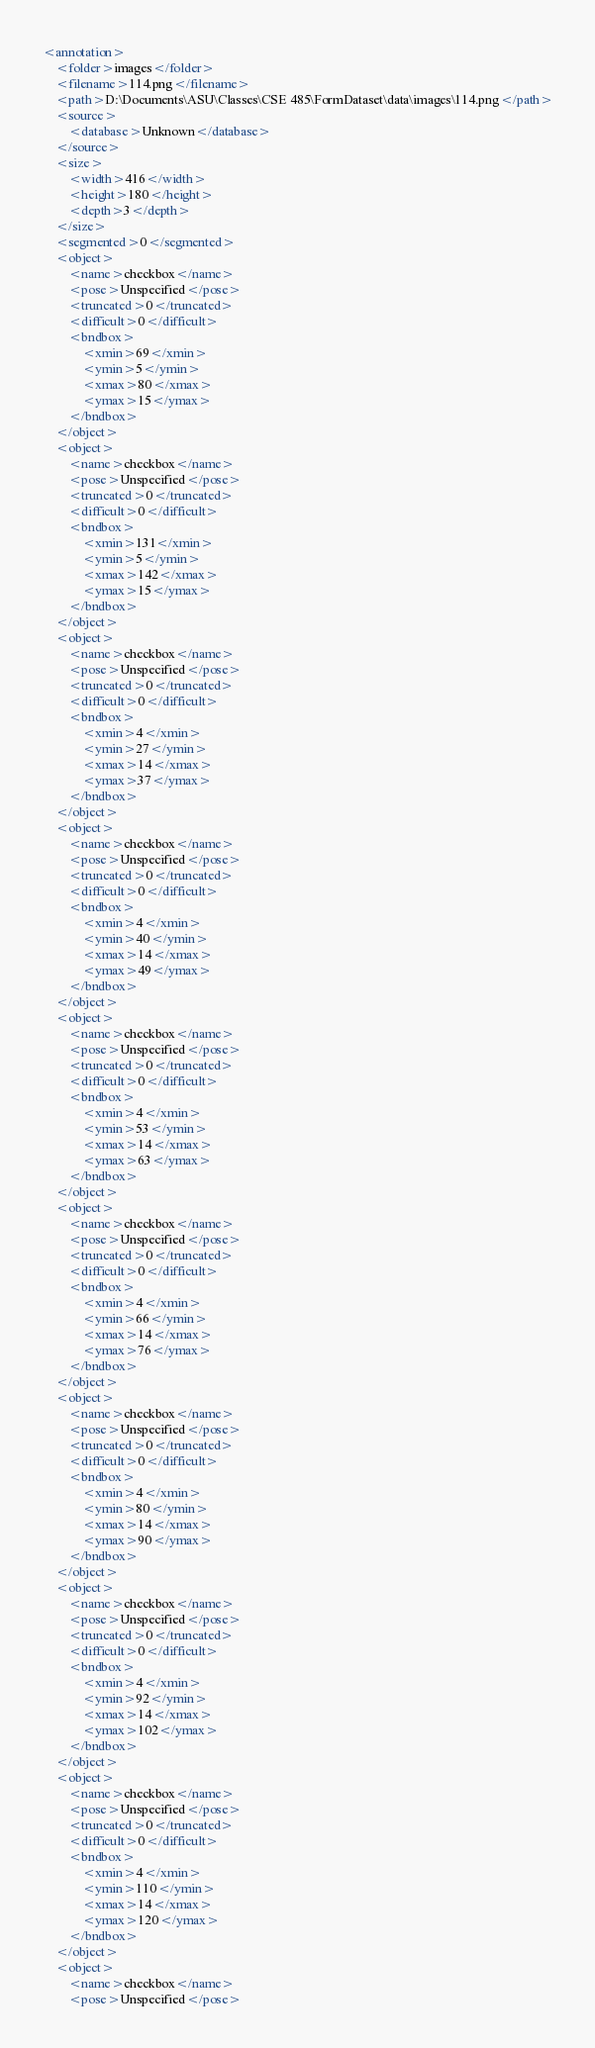Convert code to text. <code><loc_0><loc_0><loc_500><loc_500><_XML_><annotation>
	<folder>images</folder>
	<filename>114.png</filename>
	<path>D:\Documents\ASU\Classes\CSE 485\FormDataset\data\images\114.png</path>
	<source>
		<database>Unknown</database>
	</source>
	<size>
		<width>416</width>
		<height>180</height>
		<depth>3</depth>
	</size>
	<segmented>0</segmented>
	<object>
		<name>checkbox</name>
		<pose>Unspecified</pose>
		<truncated>0</truncated>
		<difficult>0</difficult>
		<bndbox>
			<xmin>69</xmin>
			<ymin>5</ymin>
			<xmax>80</xmax>
			<ymax>15</ymax>
		</bndbox>
	</object>
	<object>
		<name>checkbox</name>
		<pose>Unspecified</pose>
		<truncated>0</truncated>
		<difficult>0</difficult>
		<bndbox>
			<xmin>131</xmin>
			<ymin>5</ymin>
			<xmax>142</xmax>
			<ymax>15</ymax>
		</bndbox>
	</object>
	<object>
		<name>checkbox</name>
		<pose>Unspecified</pose>
		<truncated>0</truncated>
		<difficult>0</difficult>
		<bndbox>
			<xmin>4</xmin>
			<ymin>27</ymin>
			<xmax>14</xmax>
			<ymax>37</ymax>
		</bndbox>
	</object>
	<object>
		<name>checkbox</name>
		<pose>Unspecified</pose>
		<truncated>0</truncated>
		<difficult>0</difficult>
		<bndbox>
			<xmin>4</xmin>
			<ymin>40</ymin>
			<xmax>14</xmax>
			<ymax>49</ymax>
		</bndbox>
	</object>
	<object>
		<name>checkbox</name>
		<pose>Unspecified</pose>
		<truncated>0</truncated>
		<difficult>0</difficult>
		<bndbox>
			<xmin>4</xmin>
			<ymin>53</ymin>
			<xmax>14</xmax>
			<ymax>63</ymax>
		</bndbox>
	</object>
	<object>
		<name>checkbox</name>
		<pose>Unspecified</pose>
		<truncated>0</truncated>
		<difficult>0</difficult>
		<bndbox>
			<xmin>4</xmin>
			<ymin>66</ymin>
			<xmax>14</xmax>
			<ymax>76</ymax>
		</bndbox>
	</object>
	<object>
		<name>checkbox</name>
		<pose>Unspecified</pose>
		<truncated>0</truncated>
		<difficult>0</difficult>
		<bndbox>
			<xmin>4</xmin>
			<ymin>80</ymin>
			<xmax>14</xmax>
			<ymax>90</ymax>
		</bndbox>
	</object>
	<object>
		<name>checkbox</name>
		<pose>Unspecified</pose>
		<truncated>0</truncated>
		<difficult>0</difficult>
		<bndbox>
			<xmin>4</xmin>
			<ymin>92</ymin>
			<xmax>14</xmax>
			<ymax>102</ymax>
		</bndbox>
	</object>
	<object>
		<name>checkbox</name>
		<pose>Unspecified</pose>
		<truncated>0</truncated>
		<difficult>0</difficult>
		<bndbox>
			<xmin>4</xmin>
			<ymin>110</ymin>
			<xmax>14</xmax>
			<ymax>120</ymax>
		</bndbox>
	</object>
	<object>
		<name>checkbox</name>
		<pose>Unspecified</pose></code> 